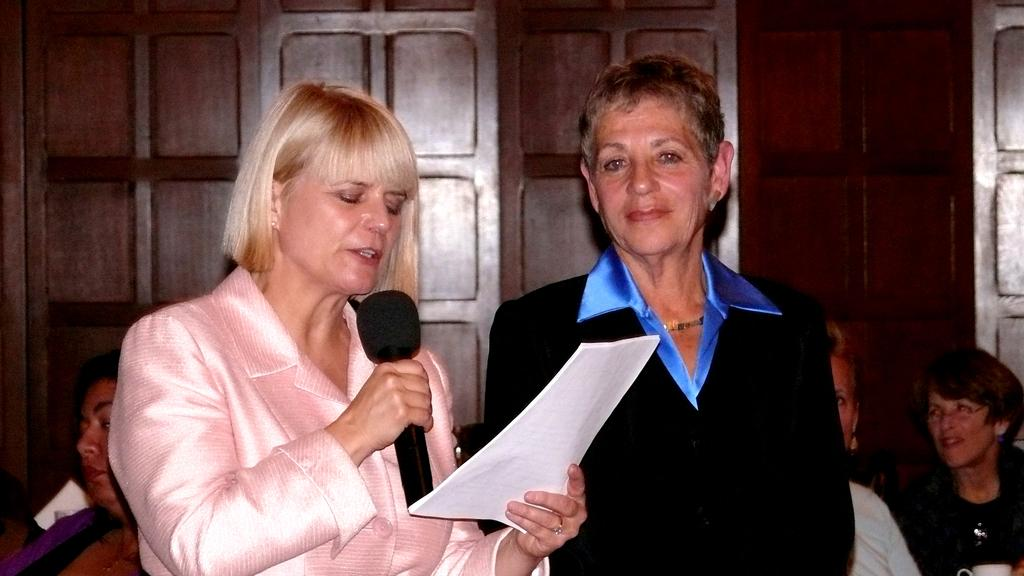How many women are present in the image? There are two women standing in the image. What is the woman on the left side holding? The woman on the left side is holding a microphone and papers in her hand. Can you describe the people in the background of the image? There are other people sitting in the background of the image. How many children are present in the image? There are no children present in the image. What type of luggage is the porter carrying in the image? There is no porter present in the image, so it is not possible to determine what type of luggage they might be carrying. 